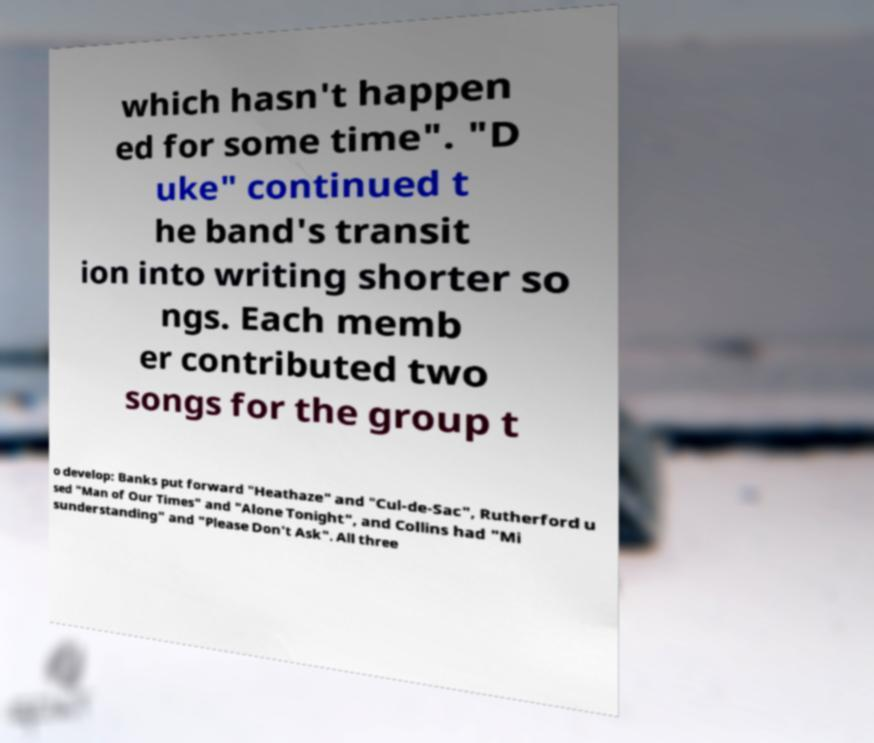Can you read and provide the text displayed in the image?This photo seems to have some interesting text. Can you extract and type it out for me? which hasn't happen ed for some time". "D uke" continued t he band's transit ion into writing shorter so ngs. Each memb er contributed two songs for the group t o develop: Banks put forward "Heathaze" and "Cul-de-Sac", Rutherford u sed "Man of Our Times" and "Alone Tonight", and Collins had "Mi sunderstanding" and "Please Don't Ask". All three 